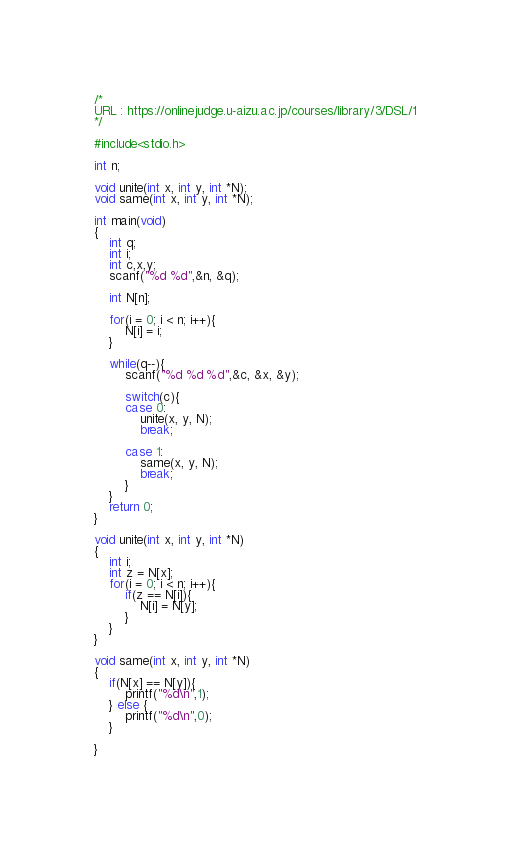Convert code to text. <code><loc_0><loc_0><loc_500><loc_500><_C_>/*
URL : https://onlinejudge.u-aizu.ac.jp/courses/library/3/DSL/1
*/

#include<stdio.h>

int n;

void unite(int x, int y, int *N);
void same(int x, int y, int *N);

int main(void)
{
	int q;
	int i;
	int c,x,y;
	scanf("%d %d",&n, &q);
	
	int N[n];
	
	for(i = 0; i < n; i++){
		N[i] = i;
	}
	
	while(q--){
		scanf("%d %d %d",&c, &x, &y);
		
		switch(c){
		case 0:
			unite(x, y, N);
			break;
			
		case 1:
			same(x, y, N);
			break;
		}
	}
	return 0;
}

void unite(int x, int y, int *N)
{
	int i;
	int z = N[x];
	for(i = 0; i < n; i++){
		if(z == N[i]){
			N[i] = N[y];
		}
	}
}

void same(int x, int y, int *N)
{
	if(N[x] == N[y]){
		printf("%d\n",1);
	} else {
		printf("%d\n",0);
	}

}
</code> 